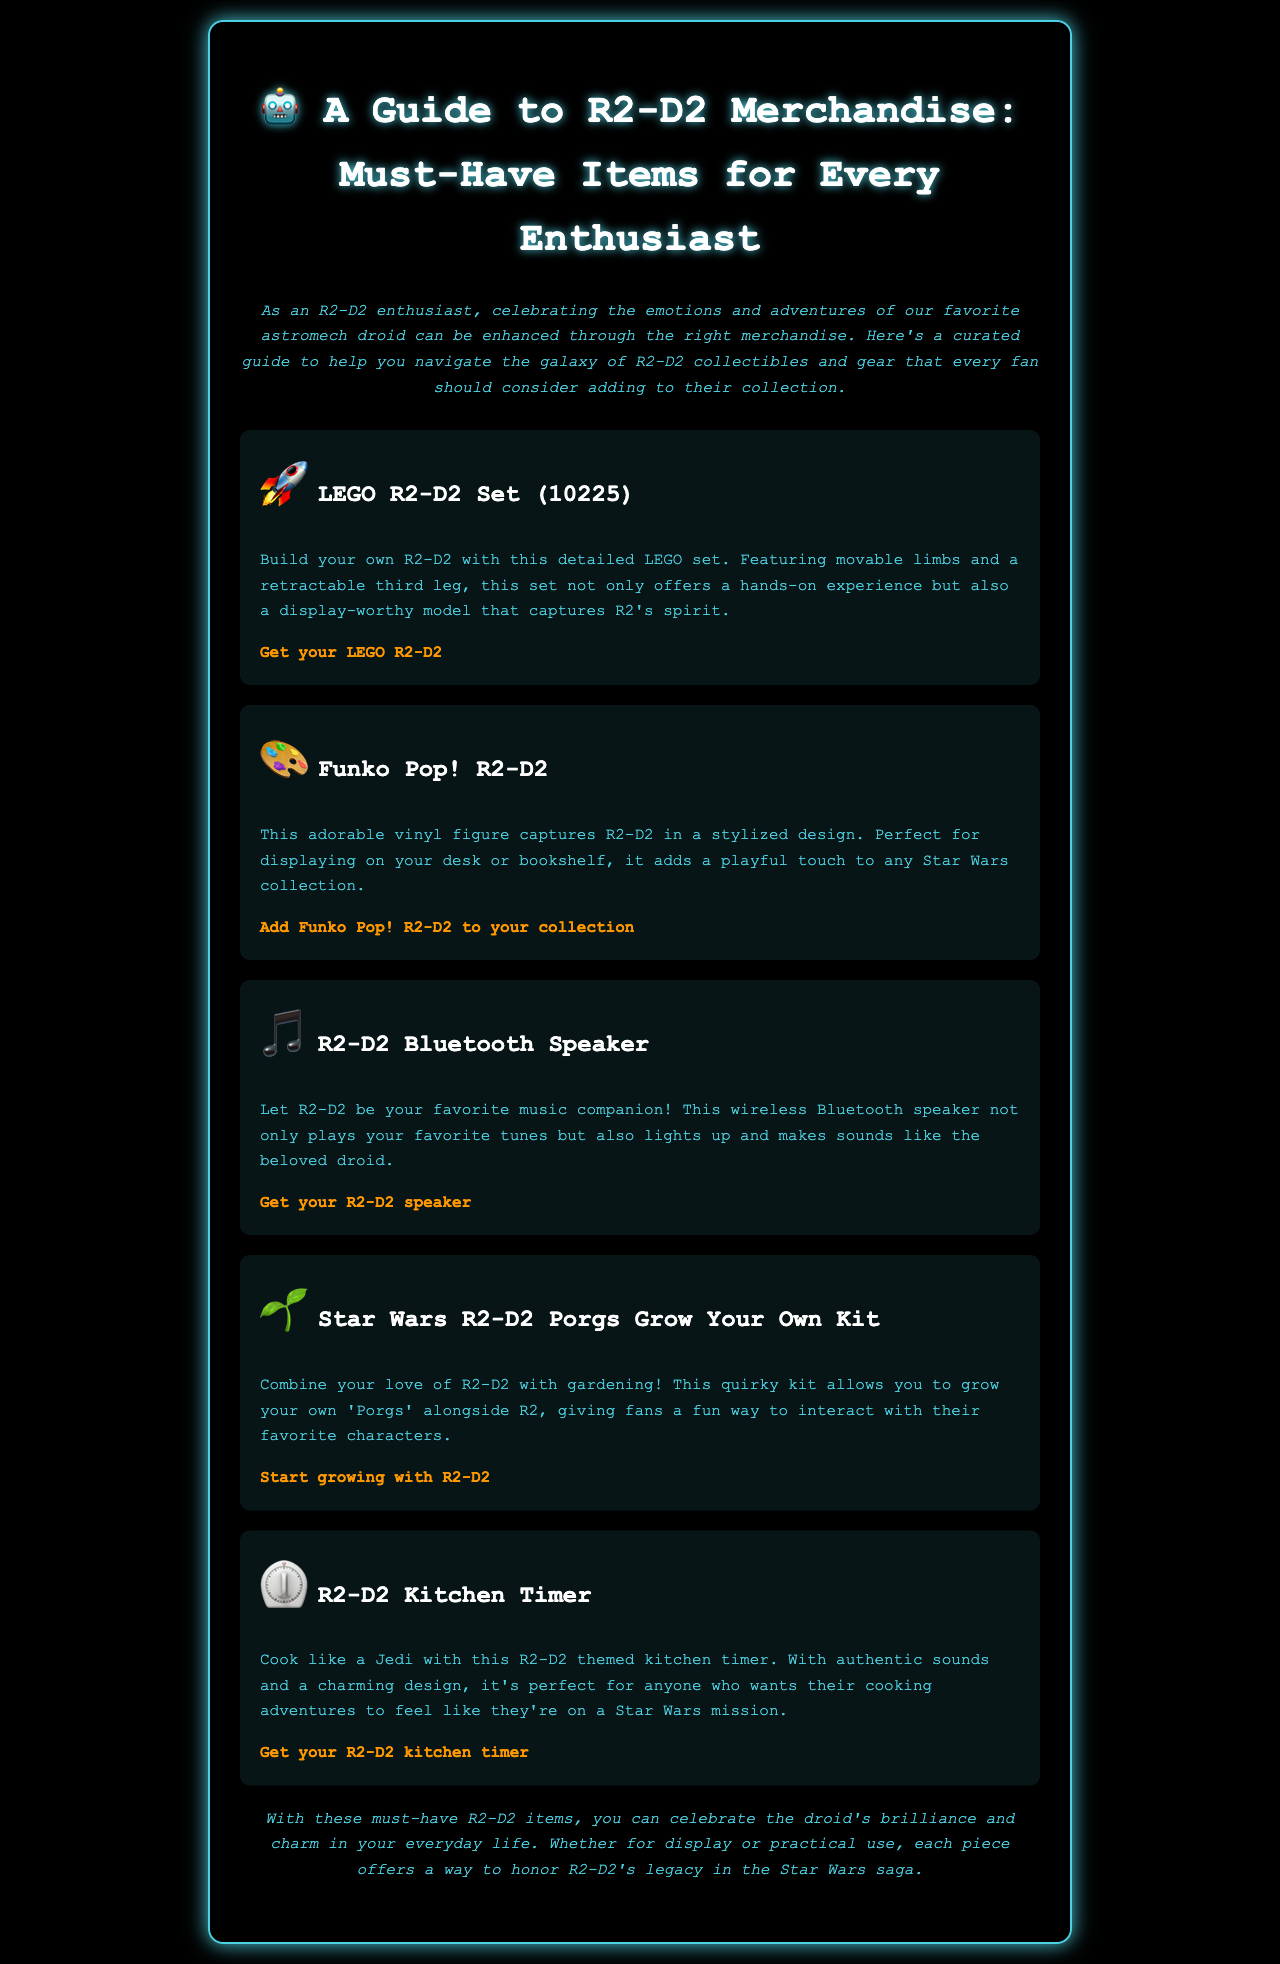What is the title of the guide? The title is prominently displayed at the top of the document, which provides a clear identification of the content.
Answer: A Guide to R2-D2 Merchandise: Must-Have Items for Every Enthusiast How many items are featured in the guide? The document lists a total of five items under R2-D2 merchandise, each with a brief description.
Answer: 5 What is the name of the LEGO set? The guide specifically names the LEGO set for R2-D2 in the merchandise list.
Answer: LEGO R2-D2 Set (10225) What type of product is the third item? The third item in the list is identified as a Bluetooth speaker, according to the description of that item.
Answer: Bluetooth Speaker Which item allows you to grow your own Porgs? The guide specifically mentions a kit that enables growing Porgs associated with R2-D2.
Answer: Star Wars R2-D2 Porgs Grow Your Own Kit How does the kitchen timer sound? The kitchen timer is described as having authentic sounds, which suggests it is themed closely to R2-D2's character.
Answer: Authentic sounds 